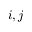<formula> <loc_0><loc_0><loc_500><loc_500>i , j</formula> 